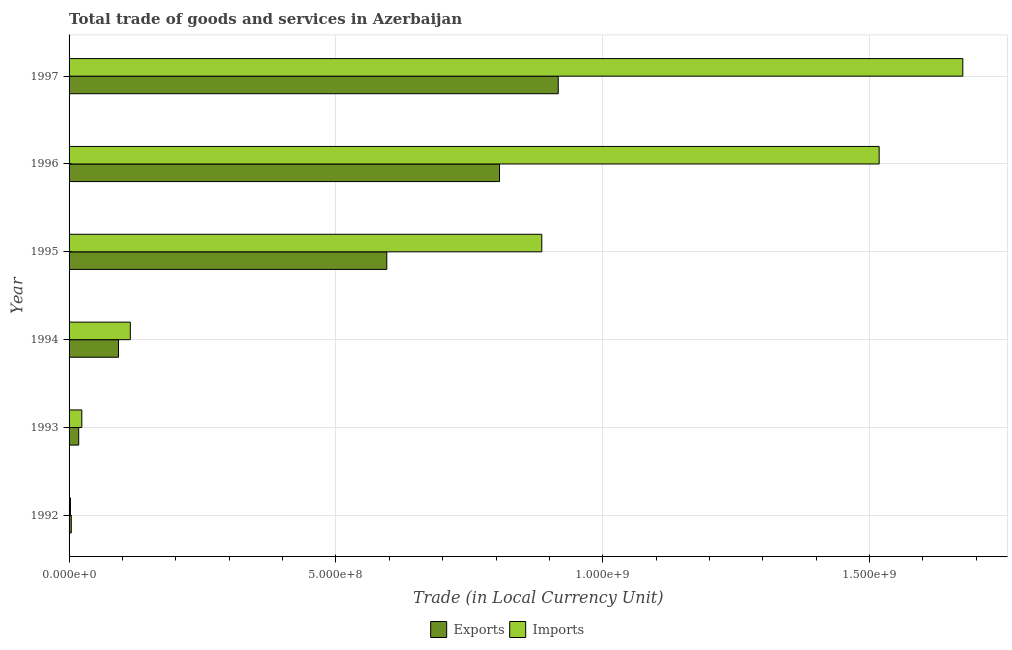How many different coloured bars are there?
Provide a succinct answer. 2. How many groups of bars are there?
Your response must be concise. 6. Are the number of bars per tick equal to the number of legend labels?
Provide a short and direct response. Yes. Are the number of bars on each tick of the Y-axis equal?
Your answer should be compact. Yes. How many bars are there on the 1st tick from the top?
Offer a terse response. 2. How many bars are there on the 2nd tick from the bottom?
Offer a terse response. 2. What is the export of goods and services in 1997?
Ensure brevity in your answer.  9.17e+08. Across all years, what is the maximum imports of goods and services?
Your answer should be very brief. 1.67e+09. Across all years, what is the minimum export of goods and services?
Provide a succinct answer. 4.16e+06. In which year was the imports of goods and services maximum?
Offer a terse response. 1997. In which year was the export of goods and services minimum?
Offer a terse response. 1992. What is the total imports of goods and services in the graph?
Offer a terse response. 4.22e+09. What is the difference between the imports of goods and services in 1992 and that in 1996?
Give a very brief answer. -1.52e+09. What is the difference between the imports of goods and services in 1997 and the export of goods and services in 1994?
Offer a terse response. 1.58e+09. What is the average export of goods and services per year?
Offer a terse response. 4.06e+08. In the year 1995, what is the difference between the export of goods and services and imports of goods and services?
Your response must be concise. -2.90e+08. In how many years, is the export of goods and services greater than 200000000 LCU?
Provide a succinct answer. 3. What is the ratio of the export of goods and services in 1996 to that in 1997?
Offer a terse response. 0.88. Is the export of goods and services in 1995 less than that in 1997?
Provide a short and direct response. Yes. What is the difference between the highest and the second highest imports of goods and services?
Ensure brevity in your answer.  1.57e+08. What is the difference between the highest and the lowest imports of goods and services?
Give a very brief answer. 1.67e+09. In how many years, is the export of goods and services greater than the average export of goods and services taken over all years?
Offer a very short reply. 3. What does the 2nd bar from the top in 1993 represents?
Your answer should be very brief. Exports. What does the 2nd bar from the bottom in 1997 represents?
Give a very brief answer. Imports. Are all the bars in the graph horizontal?
Your answer should be very brief. Yes. Are the values on the major ticks of X-axis written in scientific E-notation?
Offer a terse response. Yes. Does the graph contain any zero values?
Make the answer very short. No. Where does the legend appear in the graph?
Provide a short and direct response. Bottom center. How many legend labels are there?
Your answer should be compact. 2. What is the title of the graph?
Keep it short and to the point. Total trade of goods and services in Azerbaijan. What is the label or title of the X-axis?
Provide a succinct answer. Trade (in Local Currency Unit). What is the Trade (in Local Currency Unit) in Exports in 1992?
Provide a succinct answer. 4.16e+06. What is the Trade (in Local Currency Unit) in Imports in 1992?
Your answer should be very brief. 2.63e+06. What is the Trade (in Local Currency Unit) of Exports in 1993?
Give a very brief answer. 1.80e+07. What is the Trade (in Local Currency Unit) of Imports in 1993?
Offer a very short reply. 2.39e+07. What is the Trade (in Local Currency Unit) of Exports in 1994?
Make the answer very short. 9.26e+07. What is the Trade (in Local Currency Unit) of Imports in 1994?
Your answer should be very brief. 1.15e+08. What is the Trade (in Local Currency Unit) of Exports in 1995?
Keep it short and to the point. 5.95e+08. What is the Trade (in Local Currency Unit) of Imports in 1995?
Keep it short and to the point. 8.86e+08. What is the Trade (in Local Currency Unit) of Exports in 1996?
Your response must be concise. 8.07e+08. What is the Trade (in Local Currency Unit) of Imports in 1996?
Your response must be concise. 1.52e+09. What is the Trade (in Local Currency Unit) in Exports in 1997?
Your answer should be compact. 9.17e+08. What is the Trade (in Local Currency Unit) in Imports in 1997?
Offer a terse response. 1.67e+09. Across all years, what is the maximum Trade (in Local Currency Unit) of Exports?
Offer a very short reply. 9.17e+08. Across all years, what is the maximum Trade (in Local Currency Unit) of Imports?
Offer a very short reply. 1.67e+09. Across all years, what is the minimum Trade (in Local Currency Unit) of Exports?
Your answer should be very brief. 4.16e+06. Across all years, what is the minimum Trade (in Local Currency Unit) in Imports?
Provide a succinct answer. 2.63e+06. What is the total Trade (in Local Currency Unit) in Exports in the graph?
Give a very brief answer. 2.43e+09. What is the total Trade (in Local Currency Unit) of Imports in the graph?
Provide a succinct answer. 4.22e+09. What is the difference between the Trade (in Local Currency Unit) in Exports in 1992 and that in 1993?
Keep it short and to the point. -1.39e+07. What is the difference between the Trade (in Local Currency Unit) of Imports in 1992 and that in 1993?
Ensure brevity in your answer.  -2.12e+07. What is the difference between the Trade (in Local Currency Unit) in Exports in 1992 and that in 1994?
Provide a succinct answer. -8.85e+07. What is the difference between the Trade (in Local Currency Unit) of Imports in 1992 and that in 1994?
Your response must be concise. -1.12e+08. What is the difference between the Trade (in Local Currency Unit) in Exports in 1992 and that in 1995?
Give a very brief answer. -5.91e+08. What is the difference between the Trade (in Local Currency Unit) of Imports in 1992 and that in 1995?
Provide a succinct answer. -8.83e+08. What is the difference between the Trade (in Local Currency Unit) of Exports in 1992 and that in 1996?
Provide a succinct answer. -8.02e+08. What is the difference between the Trade (in Local Currency Unit) in Imports in 1992 and that in 1996?
Offer a very short reply. -1.52e+09. What is the difference between the Trade (in Local Currency Unit) of Exports in 1992 and that in 1997?
Ensure brevity in your answer.  -9.12e+08. What is the difference between the Trade (in Local Currency Unit) in Imports in 1992 and that in 1997?
Your answer should be very brief. -1.67e+09. What is the difference between the Trade (in Local Currency Unit) in Exports in 1993 and that in 1994?
Offer a terse response. -7.46e+07. What is the difference between the Trade (in Local Currency Unit) in Imports in 1993 and that in 1994?
Offer a very short reply. -9.09e+07. What is the difference between the Trade (in Local Currency Unit) of Exports in 1993 and that in 1995?
Your response must be concise. -5.77e+08. What is the difference between the Trade (in Local Currency Unit) in Imports in 1993 and that in 1995?
Your answer should be very brief. -8.62e+08. What is the difference between the Trade (in Local Currency Unit) of Exports in 1993 and that in 1996?
Your answer should be very brief. -7.89e+08. What is the difference between the Trade (in Local Currency Unit) of Imports in 1993 and that in 1996?
Provide a succinct answer. -1.49e+09. What is the difference between the Trade (in Local Currency Unit) in Exports in 1993 and that in 1997?
Give a very brief answer. -8.99e+08. What is the difference between the Trade (in Local Currency Unit) of Imports in 1993 and that in 1997?
Provide a short and direct response. -1.65e+09. What is the difference between the Trade (in Local Currency Unit) of Exports in 1994 and that in 1995?
Your answer should be very brief. -5.03e+08. What is the difference between the Trade (in Local Currency Unit) in Imports in 1994 and that in 1995?
Offer a terse response. -7.71e+08. What is the difference between the Trade (in Local Currency Unit) of Exports in 1994 and that in 1996?
Keep it short and to the point. -7.14e+08. What is the difference between the Trade (in Local Currency Unit) in Imports in 1994 and that in 1996?
Keep it short and to the point. -1.40e+09. What is the difference between the Trade (in Local Currency Unit) in Exports in 1994 and that in 1997?
Your response must be concise. -8.24e+08. What is the difference between the Trade (in Local Currency Unit) in Imports in 1994 and that in 1997?
Offer a terse response. -1.56e+09. What is the difference between the Trade (in Local Currency Unit) of Exports in 1995 and that in 1996?
Your answer should be compact. -2.11e+08. What is the difference between the Trade (in Local Currency Unit) of Imports in 1995 and that in 1996?
Provide a short and direct response. -6.32e+08. What is the difference between the Trade (in Local Currency Unit) in Exports in 1995 and that in 1997?
Make the answer very short. -3.21e+08. What is the difference between the Trade (in Local Currency Unit) of Imports in 1995 and that in 1997?
Your response must be concise. -7.89e+08. What is the difference between the Trade (in Local Currency Unit) of Exports in 1996 and that in 1997?
Offer a very short reply. -1.10e+08. What is the difference between the Trade (in Local Currency Unit) of Imports in 1996 and that in 1997?
Your answer should be very brief. -1.57e+08. What is the difference between the Trade (in Local Currency Unit) in Exports in 1992 and the Trade (in Local Currency Unit) in Imports in 1993?
Your answer should be very brief. -1.97e+07. What is the difference between the Trade (in Local Currency Unit) in Exports in 1992 and the Trade (in Local Currency Unit) in Imports in 1994?
Offer a terse response. -1.11e+08. What is the difference between the Trade (in Local Currency Unit) of Exports in 1992 and the Trade (in Local Currency Unit) of Imports in 1995?
Give a very brief answer. -8.82e+08. What is the difference between the Trade (in Local Currency Unit) in Exports in 1992 and the Trade (in Local Currency Unit) in Imports in 1996?
Give a very brief answer. -1.51e+09. What is the difference between the Trade (in Local Currency Unit) in Exports in 1992 and the Trade (in Local Currency Unit) in Imports in 1997?
Ensure brevity in your answer.  -1.67e+09. What is the difference between the Trade (in Local Currency Unit) of Exports in 1993 and the Trade (in Local Currency Unit) of Imports in 1994?
Provide a short and direct response. -9.67e+07. What is the difference between the Trade (in Local Currency Unit) of Exports in 1993 and the Trade (in Local Currency Unit) of Imports in 1995?
Your answer should be very brief. -8.68e+08. What is the difference between the Trade (in Local Currency Unit) of Exports in 1993 and the Trade (in Local Currency Unit) of Imports in 1996?
Provide a short and direct response. -1.50e+09. What is the difference between the Trade (in Local Currency Unit) in Exports in 1993 and the Trade (in Local Currency Unit) in Imports in 1997?
Offer a very short reply. -1.66e+09. What is the difference between the Trade (in Local Currency Unit) in Exports in 1994 and the Trade (in Local Currency Unit) in Imports in 1995?
Provide a short and direct response. -7.93e+08. What is the difference between the Trade (in Local Currency Unit) of Exports in 1994 and the Trade (in Local Currency Unit) of Imports in 1996?
Offer a terse response. -1.43e+09. What is the difference between the Trade (in Local Currency Unit) in Exports in 1994 and the Trade (in Local Currency Unit) in Imports in 1997?
Make the answer very short. -1.58e+09. What is the difference between the Trade (in Local Currency Unit) of Exports in 1995 and the Trade (in Local Currency Unit) of Imports in 1996?
Your answer should be very brief. -9.23e+08. What is the difference between the Trade (in Local Currency Unit) in Exports in 1995 and the Trade (in Local Currency Unit) in Imports in 1997?
Offer a terse response. -1.08e+09. What is the difference between the Trade (in Local Currency Unit) in Exports in 1996 and the Trade (in Local Currency Unit) in Imports in 1997?
Provide a short and direct response. -8.68e+08. What is the average Trade (in Local Currency Unit) in Exports per year?
Your answer should be compact. 4.06e+08. What is the average Trade (in Local Currency Unit) of Imports per year?
Offer a very short reply. 7.03e+08. In the year 1992, what is the difference between the Trade (in Local Currency Unit) of Exports and Trade (in Local Currency Unit) of Imports?
Ensure brevity in your answer.  1.52e+06. In the year 1993, what is the difference between the Trade (in Local Currency Unit) in Exports and Trade (in Local Currency Unit) in Imports?
Keep it short and to the point. -5.83e+06. In the year 1994, what is the difference between the Trade (in Local Currency Unit) in Exports and Trade (in Local Currency Unit) in Imports?
Your answer should be compact. -2.21e+07. In the year 1995, what is the difference between the Trade (in Local Currency Unit) in Exports and Trade (in Local Currency Unit) in Imports?
Your answer should be very brief. -2.90e+08. In the year 1996, what is the difference between the Trade (in Local Currency Unit) in Exports and Trade (in Local Currency Unit) in Imports?
Make the answer very short. -7.11e+08. In the year 1997, what is the difference between the Trade (in Local Currency Unit) of Exports and Trade (in Local Currency Unit) of Imports?
Offer a terse response. -7.58e+08. What is the ratio of the Trade (in Local Currency Unit) in Exports in 1992 to that in 1993?
Provide a succinct answer. 0.23. What is the ratio of the Trade (in Local Currency Unit) of Imports in 1992 to that in 1993?
Provide a short and direct response. 0.11. What is the ratio of the Trade (in Local Currency Unit) in Exports in 1992 to that in 1994?
Make the answer very short. 0.04. What is the ratio of the Trade (in Local Currency Unit) of Imports in 1992 to that in 1994?
Make the answer very short. 0.02. What is the ratio of the Trade (in Local Currency Unit) in Exports in 1992 to that in 1995?
Your answer should be very brief. 0.01. What is the ratio of the Trade (in Local Currency Unit) of Imports in 1992 to that in 1995?
Provide a succinct answer. 0. What is the ratio of the Trade (in Local Currency Unit) of Exports in 1992 to that in 1996?
Provide a short and direct response. 0.01. What is the ratio of the Trade (in Local Currency Unit) of Imports in 1992 to that in 1996?
Offer a terse response. 0. What is the ratio of the Trade (in Local Currency Unit) in Exports in 1992 to that in 1997?
Your response must be concise. 0. What is the ratio of the Trade (in Local Currency Unit) of Imports in 1992 to that in 1997?
Provide a succinct answer. 0. What is the ratio of the Trade (in Local Currency Unit) in Exports in 1993 to that in 1994?
Your answer should be compact. 0.19. What is the ratio of the Trade (in Local Currency Unit) of Imports in 1993 to that in 1994?
Your answer should be compact. 0.21. What is the ratio of the Trade (in Local Currency Unit) in Exports in 1993 to that in 1995?
Make the answer very short. 0.03. What is the ratio of the Trade (in Local Currency Unit) in Imports in 1993 to that in 1995?
Your answer should be compact. 0.03. What is the ratio of the Trade (in Local Currency Unit) of Exports in 1993 to that in 1996?
Give a very brief answer. 0.02. What is the ratio of the Trade (in Local Currency Unit) in Imports in 1993 to that in 1996?
Provide a succinct answer. 0.02. What is the ratio of the Trade (in Local Currency Unit) in Exports in 1993 to that in 1997?
Offer a terse response. 0.02. What is the ratio of the Trade (in Local Currency Unit) of Imports in 1993 to that in 1997?
Your answer should be compact. 0.01. What is the ratio of the Trade (in Local Currency Unit) of Exports in 1994 to that in 1995?
Ensure brevity in your answer.  0.16. What is the ratio of the Trade (in Local Currency Unit) in Imports in 1994 to that in 1995?
Offer a very short reply. 0.13. What is the ratio of the Trade (in Local Currency Unit) of Exports in 1994 to that in 1996?
Provide a succinct answer. 0.11. What is the ratio of the Trade (in Local Currency Unit) of Imports in 1994 to that in 1996?
Keep it short and to the point. 0.08. What is the ratio of the Trade (in Local Currency Unit) in Exports in 1994 to that in 1997?
Your answer should be compact. 0.1. What is the ratio of the Trade (in Local Currency Unit) of Imports in 1994 to that in 1997?
Offer a terse response. 0.07. What is the ratio of the Trade (in Local Currency Unit) of Exports in 1995 to that in 1996?
Make the answer very short. 0.74. What is the ratio of the Trade (in Local Currency Unit) in Imports in 1995 to that in 1996?
Ensure brevity in your answer.  0.58. What is the ratio of the Trade (in Local Currency Unit) of Exports in 1995 to that in 1997?
Offer a terse response. 0.65. What is the ratio of the Trade (in Local Currency Unit) in Imports in 1995 to that in 1997?
Provide a succinct answer. 0.53. What is the ratio of the Trade (in Local Currency Unit) in Imports in 1996 to that in 1997?
Keep it short and to the point. 0.91. What is the difference between the highest and the second highest Trade (in Local Currency Unit) in Exports?
Your answer should be compact. 1.10e+08. What is the difference between the highest and the second highest Trade (in Local Currency Unit) in Imports?
Your answer should be compact. 1.57e+08. What is the difference between the highest and the lowest Trade (in Local Currency Unit) in Exports?
Ensure brevity in your answer.  9.12e+08. What is the difference between the highest and the lowest Trade (in Local Currency Unit) in Imports?
Offer a terse response. 1.67e+09. 